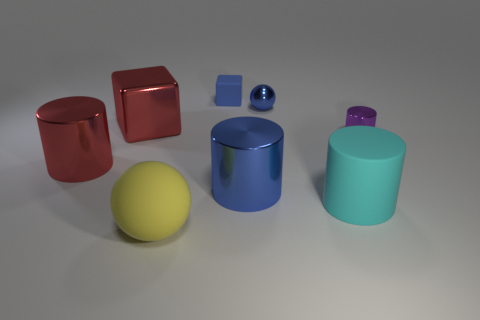Subtract all red cylinders. How many cylinders are left? 3 Add 1 large gray cubes. How many objects exist? 9 Subtract all purple cylinders. How many cylinders are left? 3 Subtract 1 cylinders. How many cylinders are left? 3 Subtract all spheres. How many objects are left? 6 Subtract 1 cyan cylinders. How many objects are left? 7 Subtract all cyan spheres. Subtract all red blocks. How many spheres are left? 2 Subtract all brown metal cylinders. Subtract all big cyan cylinders. How many objects are left? 7 Add 1 tiny purple shiny cylinders. How many tiny purple shiny cylinders are left? 2 Add 8 large metallic cylinders. How many large metallic cylinders exist? 10 